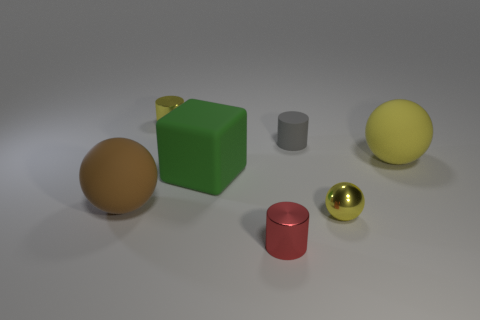Subtract all yellow cylinders. How many yellow spheres are left? 2 Subtract all metal cylinders. How many cylinders are left? 1 Add 3 tiny objects. How many objects exist? 10 Subtract 1 spheres. How many spheres are left? 2 Subtract all cylinders. How many objects are left? 4 Subtract all blocks. Subtract all big shiny spheres. How many objects are left? 6 Add 2 big green rubber blocks. How many big green rubber blocks are left? 3 Add 7 tiny purple metal cylinders. How many tiny purple metal cylinders exist? 7 Subtract 0 purple cubes. How many objects are left? 7 Subtract all blue cylinders. Subtract all brown balls. How many cylinders are left? 3 